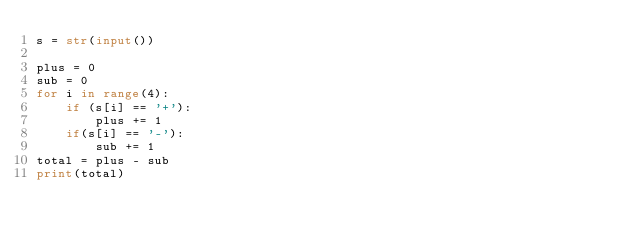Convert code to text. <code><loc_0><loc_0><loc_500><loc_500><_Python_>s = str(input())

plus = 0
sub = 0
for i in range(4):
    if (s[i] == '+'):
        plus += 1
    if(s[i] == '-'):
        sub += 1
total = plus - sub
print(total)</code> 